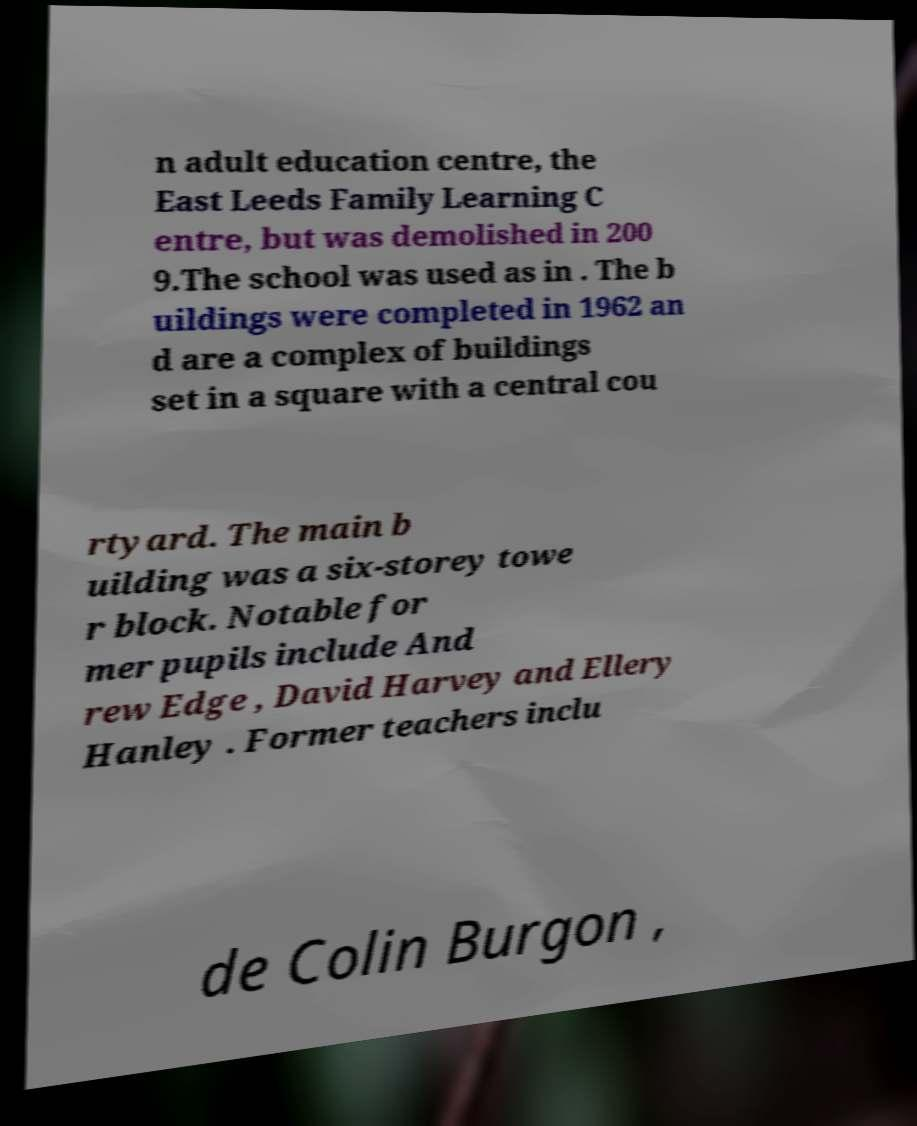Could you extract and type out the text from this image? n adult education centre, the East Leeds Family Learning C entre, but was demolished in 200 9.The school was used as in . The b uildings were completed in 1962 an d are a complex of buildings set in a square with a central cou rtyard. The main b uilding was a six-storey towe r block. Notable for mer pupils include And rew Edge , David Harvey and Ellery Hanley . Former teachers inclu de Colin Burgon , 